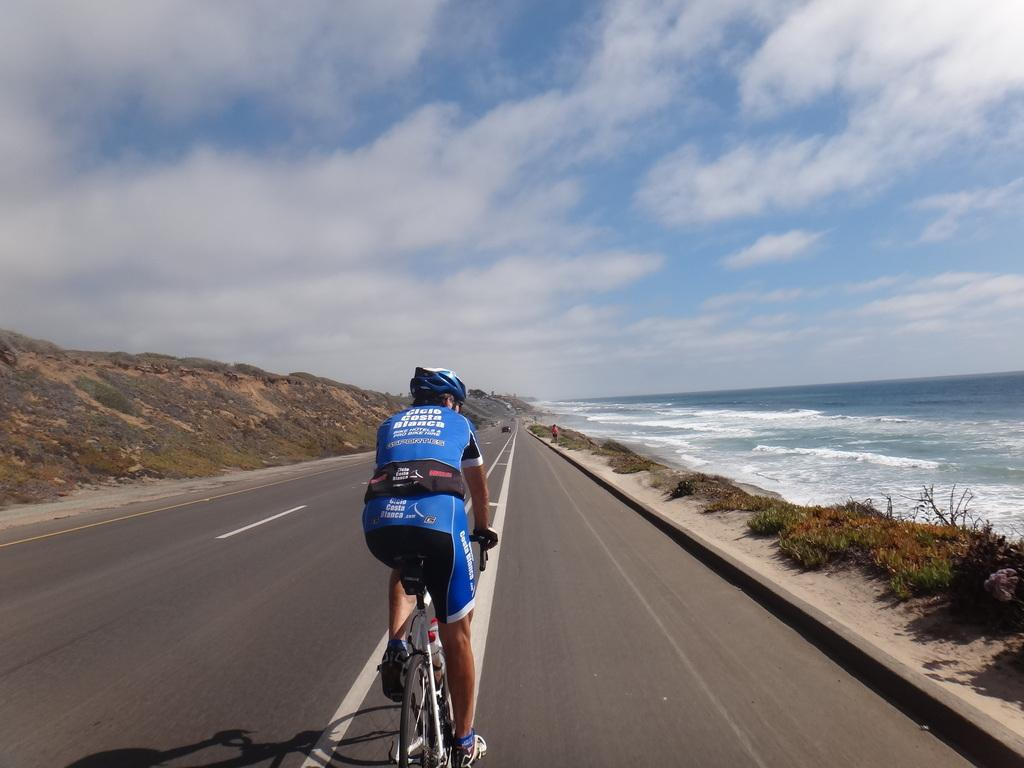What is the person in the image doing? There is a person riding a bicycle in the image. What is the person wearing while riding the bicycle? The person is wearing a blue dress. What type of terrain can be seen in the image? There are rocks, water, and grass visible in the image. What is the color of the sky in the image? The sky is blue and white in color. What type of brick is being used to measure the distance between the rocks in the image? There is no brick present in the image, nor is there any measuring activity taking place. Additionally, there are no rocks close enough to each other to require measuring the distance between them. 